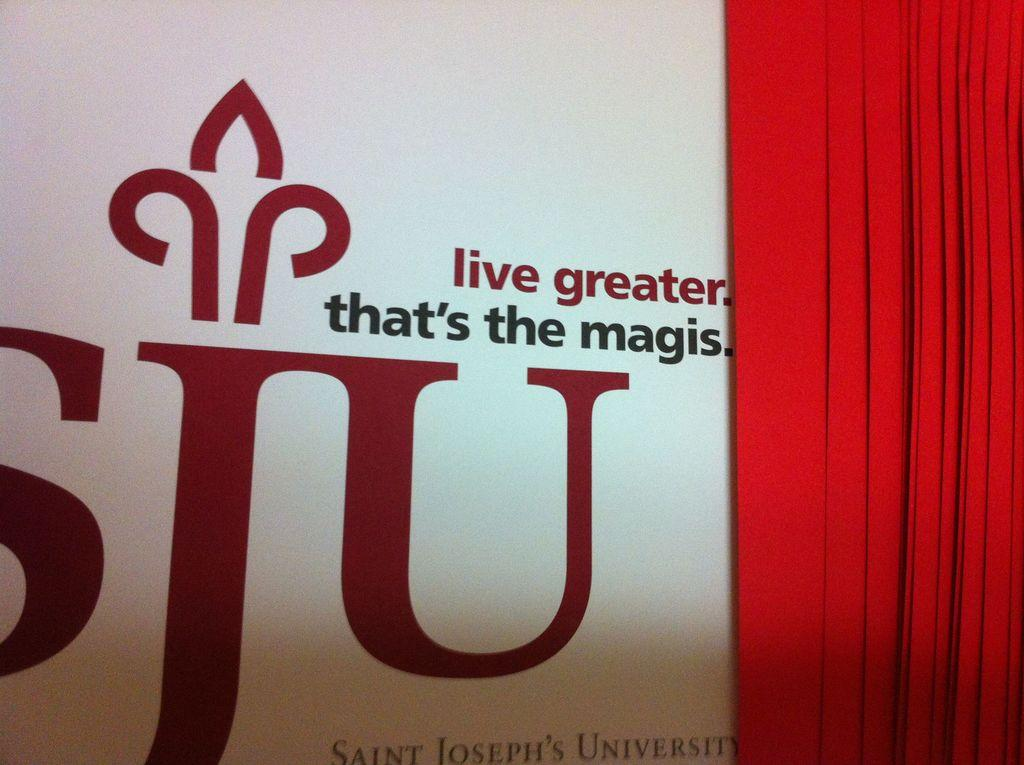Provide a one-sentence caption for the provided image. A statement and logo from Saint Joseph's University is on the wall behind a curtain. 